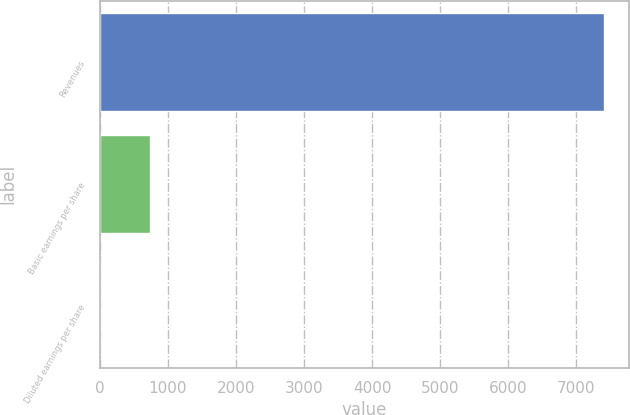Convert chart to OTSL. <chart><loc_0><loc_0><loc_500><loc_500><bar_chart><fcel>Revenues<fcel>Basic earnings per share<fcel>Diluted earnings per share<nl><fcel>7406<fcel>741.07<fcel>0.52<nl></chart> 